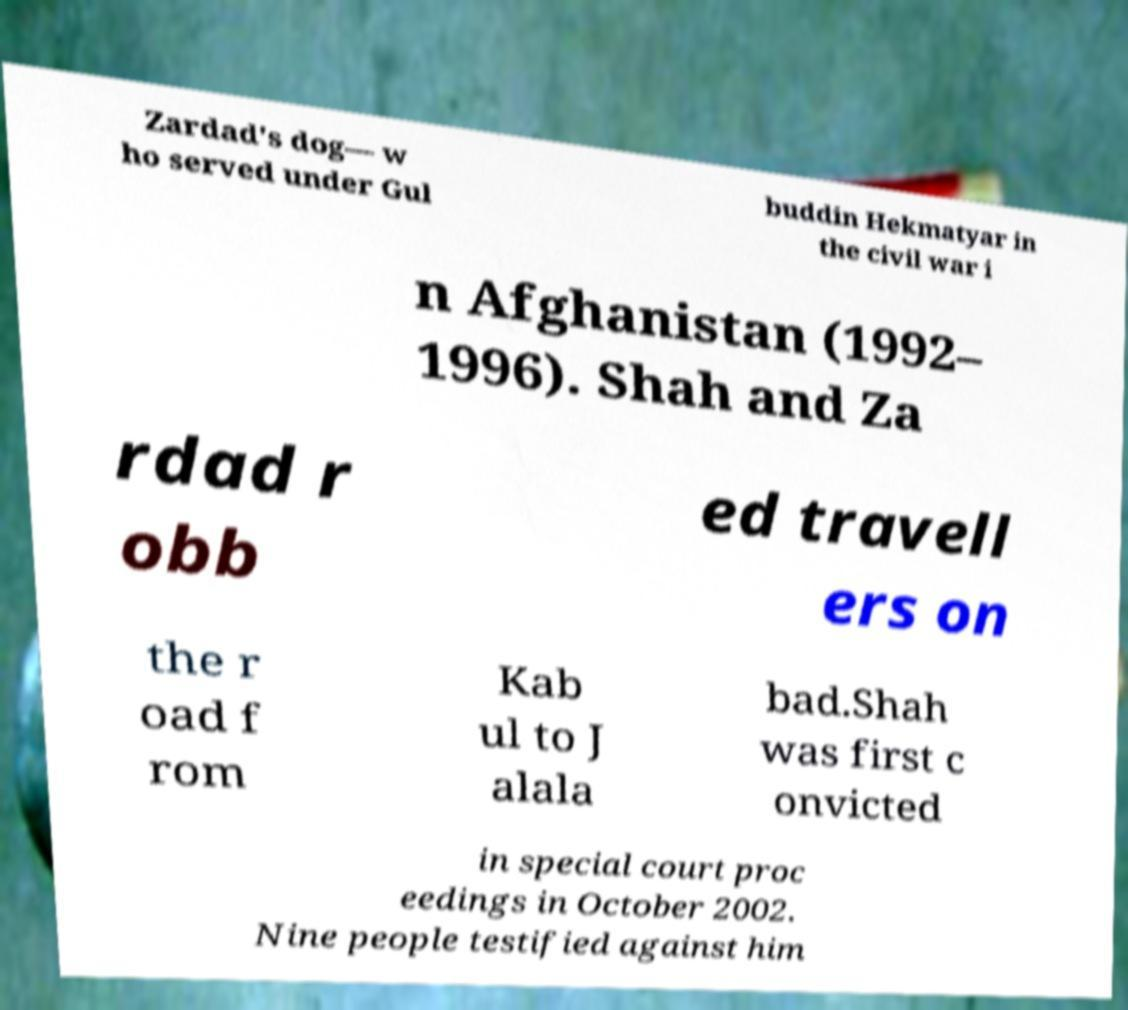What messages or text are displayed in this image? I need them in a readable, typed format. Zardad's dog— w ho served under Gul buddin Hekmatyar in the civil war i n Afghanistan (1992– 1996). Shah and Za rdad r obb ed travell ers on the r oad f rom Kab ul to J alala bad.Shah was first c onvicted in special court proc eedings in October 2002. Nine people testified against him 